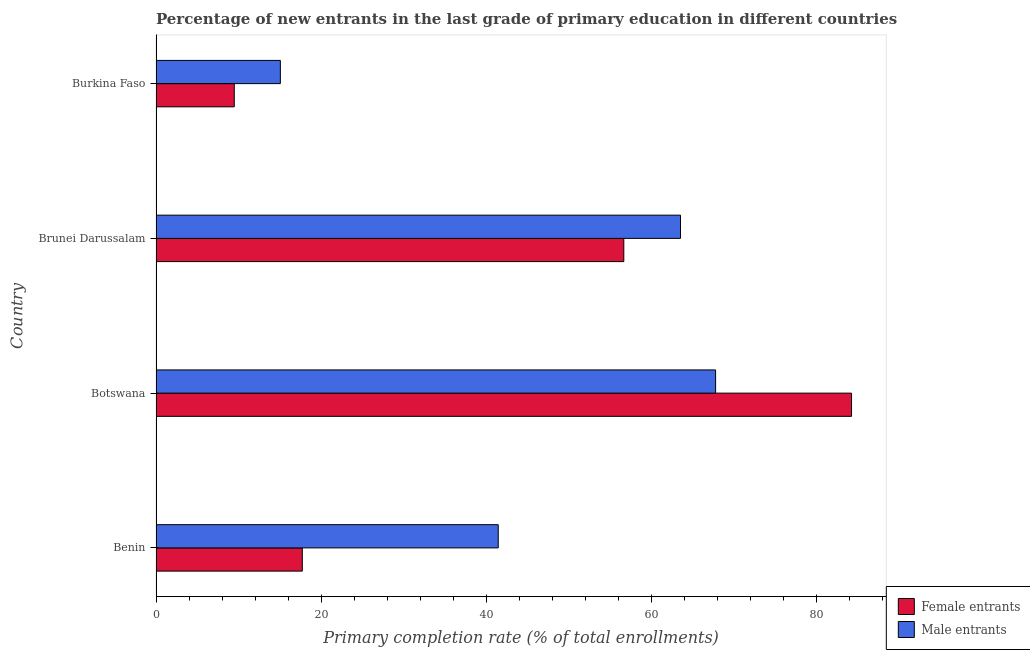How many different coloured bars are there?
Your answer should be compact. 2. How many groups of bars are there?
Your response must be concise. 4. Are the number of bars on each tick of the Y-axis equal?
Give a very brief answer. Yes. How many bars are there on the 1st tick from the top?
Offer a terse response. 2. What is the label of the 1st group of bars from the top?
Give a very brief answer. Burkina Faso. What is the primary completion rate of male entrants in Burkina Faso?
Your answer should be compact. 15.06. Across all countries, what is the maximum primary completion rate of female entrants?
Offer a very short reply. 84.24. Across all countries, what is the minimum primary completion rate of female entrants?
Your answer should be compact. 9.48. In which country was the primary completion rate of male entrants maximum?
Your response must be concise. Botswana. In which country was the primary completion rate of female entrants minimum?
Offer a very short reply. Burkina Faso. What is the total primary completion rate of female entrants in the graph?
Ensure brevity in your answer.  168.1. What is the difference between the primary completion rate of female entrants in Botswana and that in Brunei Darussalam?
Ensure brevity in your answer.  27.58. What is the difference between the primary completion rate of female entrants in Botswana and the primary completion rate of male entrants in Benin?
Your response must be concise. 42.79. What is the average primary completion rate of male entrants per country?
Offer a terse response. 46.95. What is the difference between the primary completion rate of female entrants and primary completion rate of male entrants in Brunei Darussalam?
Offer a very short reply. -6.87. Is the primary completion rate of male entrants in Botswana less than that in Burkina Faso?
Your response must be concise. No. Is the difference between the primary completion rate of male entrants in Benin and Botswana greater than the difference between the primary completion rate of female entrants in Benin and Botswana?
Offer a terse response. Yes. What is the difference between the highest and the second highest primary completion rate of female entrants?
Your answer should be compact. 27.58. What is the difference between the highest and the lowest primary completion rate of male entrants?
Provide a short and direct response. 52.72. What does the 1st bar from the top in Benin represents?
Your answer should be very brief. Male entrants. What does the 1st bar from the bottom in Brunei Darussalam represents?
Offer a terse response. Female entrants. How many bars are there?
Your answer should be compact. 8. Are all the bars in the graph horizontal?
Your answer should be very brief. Yes. Does the graph contain any zero values?
Provide a short and direct response. No. Does the graph contain grids?
Give a very brief answer. No. Where does the legend appear in the graph?
Your response must be concise. Bottom right. How many legend labels are there?
Offer a terse response. 2. How are the legend labels stacked?
Your answer should be very brief. Vertical. What is the title of the graph?
Ensure brevity in your answer.  Percentage of new entrants in the last grade of primary education in different countries. Does "Broad money growth" appear as one of the legend labels in the graph?
Ensure brevity in your answer.  No. What is the label or title of the X-axis?
Give a very brief answer. Primary completion rate (% of total enrollments). What is the Primary completion rate (% of total enrollments) in Female entrants in Benin?
Your answer should be very brief. 17.72. What is the Primary completion rate (% of total enrollments) of Male entrants in Benin?
Provide a short and direct response. 41.45. What is the Primary completion rate (% of total enrollments) of Female entrants in Botswana?
Provide a succinct answer. 84.24. What is the Primary completion rate (% of total enrollments) of Male entrants in Botswana?
Give a very brief answer. 67.78. What is the Primary completion rate (% of total enrollments) of Female entrants in Brunei Darussalam?
Keep it short and to the point. 56.66. What is the Primary completion rate (% of total enrollments) in Male entrants in Brunei Darussalam?
Make the answer very short. 63.53. What is the Primary completion rate (% of total enrollments) in Female entrants in Burkina Faso?
Provide a succinct answer. 9.48. What is the Primary completion rate (% of total enrollments) in Male entrants in Burkina Faso?
Offer a very short reply. 15.06. Across all countries, what is the maximum Primary completion rate (% of total enrollments) of Female entrants?
Provide a succinct answer. 84.24. Across all countries, what is the maximum Primary completion rate (% of total enrollments) in Male entrants?
Your answer should be compact. 67.78. Across all countries, what is the minimum Primary completion rate (% of total enrollments) in Female entrants?
Make the answer very short. 9.48. Across all countries, what is the minimum Primary completion rate (% of total enrollments) in Male entrants?
Your response must be concise. 15.06. What is the total Primary completion rate (% of total enrollments) in Female entrants in the graph?
Your response must be concise. 168.1. What is the total Primary completion rate (% of total enrollments) in Male entrants in the graph?
Your answer should be compact. 187.82. What is the difference between the Primary completion rate (% of total enrollments) of Female entrants in Benin and that in Botswana?
Make the answer very short. -66.53. What is the difference between the Primary completion rate (% of total enrollments) in Male entrants in Benin and that in Botswana?
Give a very brief answer. -26.33. What is the difference between the Primary completion rate (% of total enrollments) in Female entrants in Benin and that in Brunei Darussalam?
Provide a succinct answer. -38.94. What is the difference between the Primary completion rate (% of total enrollments) of Male entrants in Benin and that in Brunei Darussalam?
Give a very brief answer. -22.08. What is the difference between the Primary completion rate (% of total enrollments) of Female entrants in Benin and that in Burkina Faso?
Your answer should be compact. 8.24. What is the difference between the Primary completion rate (% of total enrollments) of Male entrants in Benin and that in Burkina Faso?
Offer a very short reply. 26.39. What is the difference between the Primary completion rate (% of total enrollments) in Female entrants in Botswana and that in Brunei Darussalam?
Provide a succinct answer. 27.58. What is the difference between the Primary completion rate (% of total enrollments) in Male entrants in Botswana and that in Brunei Darussalam?
Offer a very short reply. 4.25. What is the difference between the Primary completion rate (% of total enrollments) of Female entrants in Botswana and that in Burkina Faso?
Your answer should be compact. 74.77. What is the difference between the Primary completion rate (% of total enrollments) in Male entrants in Botswana and that in Burkina Faso?
Your response must be concise. 52.72. What is the difference between the Primary completion rate (% of total enrollments) of Female entrants in Brunei Darussalam and that in Burkina Faso?
Give a very brief answer. 47.18. What is the difference between the Primary completion rate (% of total enrollments) of Male entrants in Brunei Darussalam and that in Burkina Faso?
Provide a succinct answer. 48.47. What is the difference between the Primary completion rate (% of total enrollments) of Female entrants in Benin and the Primary completion rate (% of total enrollments) of Male entrants in Botswana?
Offer a terse response. -50.06. What is the difference between the Primary completion rate (% of total enrollments) in Female entrants in Benin and the Primary completion rate (% of total enrollments) in Male entrants in Brunei Darussalam?
Offer a very short reply. -45.81. What is the difference between the Primary completion rate (% of total enrollments) in Female entrants in Benin and the Primary completion rate (% of total enrollments) in Male entrants in Burkina Faso?
Keep it short and to the point. 2.66. What is the difference between the Primary completion rate (% of total enrollments) of Female entrants in Botswana and the Primary completion rate (% of total enrollments) of Male entrants in Brunei Darussalam?
Keep it short and to the point. 20.72. What is the difference between the Primary completion rate (% of total enrollments) in Female entrants in Botswana and the Primary completion rate (% of total enrollments) in Male entrants in Burkina Faso?
Your answer should be compact. 69.18. What is the difference between the Primary completion rate (% of total enrollments) in Female entrants in Brunei Darussalam and the Primary completion rate (% of total enrollments) in Male entrants in Burkina Faso?
Offer a very short reply. 41.6. What is the average Primary completion rate (% of total enrollments) in Female entrants per country?
Offer a very short reply. 42.02. What is the average Primary completion rate (% of total enrollments) of Male entrants per country?
Provide a succinct answer. 46.95. What is the difference between the Primary completion rate (% of total enrollments) of Female entrants and Primary completion rate (% of total enrollments) of Male entrants in Benin?
Provide a succinct answer. -23.73. What is the difference between the Primary completion rate (% of total enrollments) of Female entrants and Primary completion rate (% of total enrollments) of Male entrants in Botswana?
Make the answer very short. 16.46. What is the difference between the Primary completion rate (% of total enrollments) in Female entrants and Primary completion rate (% of total enrollments) in Male entrants in Brunei Darussalam?
Provide a succinct answer. -6.87. What is the difference between the Primary completion rate (% of total enrollments) in Female entrants and Primary completion rate (% of total enrollments) in Male entrants in Burkina Faso?
Your answer should be compact. -5.58. What is the ratio of the Primary completion rate (% of total enrollments) in Female entrants in Benin to that in Botswana?
Your answer should be compact. 0.21. What is the ratio of the Primary completion rate (% of total enrollments) of Male entrants in Benin to that in Botswana?
Give a very brief answer. 0.61. What is the ratio of the Primary completion rate (% of total enrollments) of Female entrants in Benin to that in Brunei Darussalam?
Give a very brief answer. 0.31. What is the ratio of the Primary completion rate (% of total enrollments) of Male entrants in Benin to that in Brunei Darussalam?
Offer a very short reply. 0.65. What is the ratio of the Primary completion rate (% of total enrollments) in Female entrants in Benin to that in Burkina Faso?
Your response must be concise. 1.87. What is the ratio of the Primary completion rate (% of total enrollments) in Male entrants in Benin to that in Burkina Faso?
Ensure brevity in your answer.  2.75. What is the ratio of the Primary completion rate (% of total enrollments) in Female entrants in Botswana to that in Brunei Darussalam?
Provide a succinct answer. 1.49. What is the ratio of the Primary completion rate (% of total enrollments) of Male entrants in Botswana to that in Brunei Darussalam?
Give a very brief answer. 1.07. What is the ratio of the Primary completion rate (% of total enrollments) in Female entrants in Botswana to that in Burkina Faso?
Give a very brief answer. 8.89. What is the ratio of the Primary completion rate (% of total enrollments) of Male entrants in Botswana to that in Burkina Faso?
Offer a very short reply. 4.5. What is the ratio of the Primary completion rate (% of total enrollments) in Female entrants in Brunei Darussalam to that in Burkina Faso?
Provide a short and direct response. 5.98. What is the ratio of the Primary completion rate (% of total enrollments) of Male entrants in Brunei Darussalam to that in Burkina Faso?
Provide a succinct answer. 4.22. What is the difference between the highest and the second highest Primary completion rate (% of total enrollments) in Female entrants?
Offer a very short reply. 27.58. What is the difference between the highest and the second highest Primary completion rate (% of total enrollments) in Male entrants?
Keep it short and to the point. 4.25. What is the difference between the highest and the lowest Primary completion rate (% of total enrollments) of Female entrants?
Your answer should be compact. 74.77. What is the difference between the highest and the lowest Primary completion rate (% of total enrollments) of Male entrants?
Offer a very short reply. 52.72. 